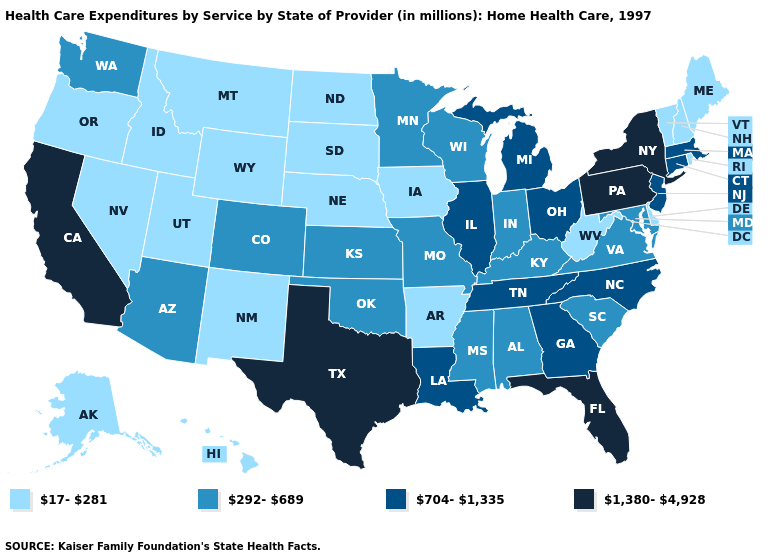Does Oregon have the lowest value in the West?
Short answer required. Yes. Name the states that have a value in the range 704-1,335?
Quick response, please. Connecticut, Georgia, Illinois, Louisiana, Massachusetts, Michigan, New Jersey, North Carolina, Ohio, Tennessee. Does Washington have the same value as Wyoming?
Give a very brief answer. No. What is the lowest value in the USA?
Keep it brief. 17-281. What is the value of Wyoming?
Answer briefly. 17-281. Does Texas have the highest value in the USA?
Be succinct. Yes. Among the states that border Tennessee , which have the highest value?
Answer briefly. Georgia, North Carolina. What is the highest value in states that border West Virginia?
Answer briefly. 1,380-4,928. Does the first symbol in the legend represent the smallest category?
Write a very short answer. Yes. What is the lowest value in the USA?
Concise answer only. 17-281. What is the value of Hawaii?
Concise answer only. 17-281. Does West Virginia have the highest value in the USA?
Give a very brief answer. No. Does the first symbol in the legend represent the smallest category?
Write a very short answer. Yes. Does the first symbol in the legend represent the smallest category?
Concise answer only. Yes. Is the legend a continuous bar?
Short answer required. No. 